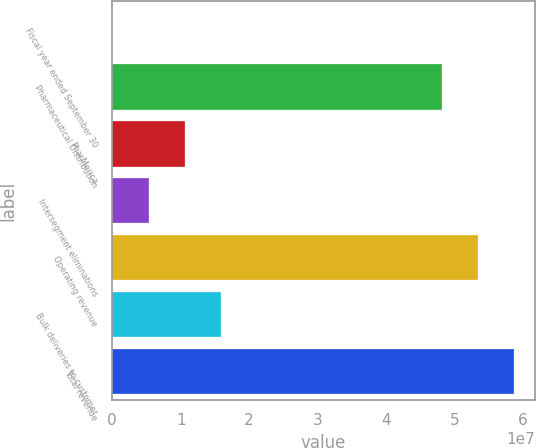<chart> <loc_0><loc_0><loc_500><loc_500><bar_chart><fcel>Fiscal year ended September 30<fcel>Pharmaceutical Distribution<fcel>PharMerica<fcel>Intersegment eliminations<fcel>Operating revenue<fcel>Bulk deliveries to customer<fcel>Total revenue<nl><fcel>2004<fcel>4.8113e+07<fcel>1.06258e+07<fcel>5.31388e+06<fcel>5.34249e+07<fcel>1.59376e+07<fcel>5.87368e+07<nl></chart> 